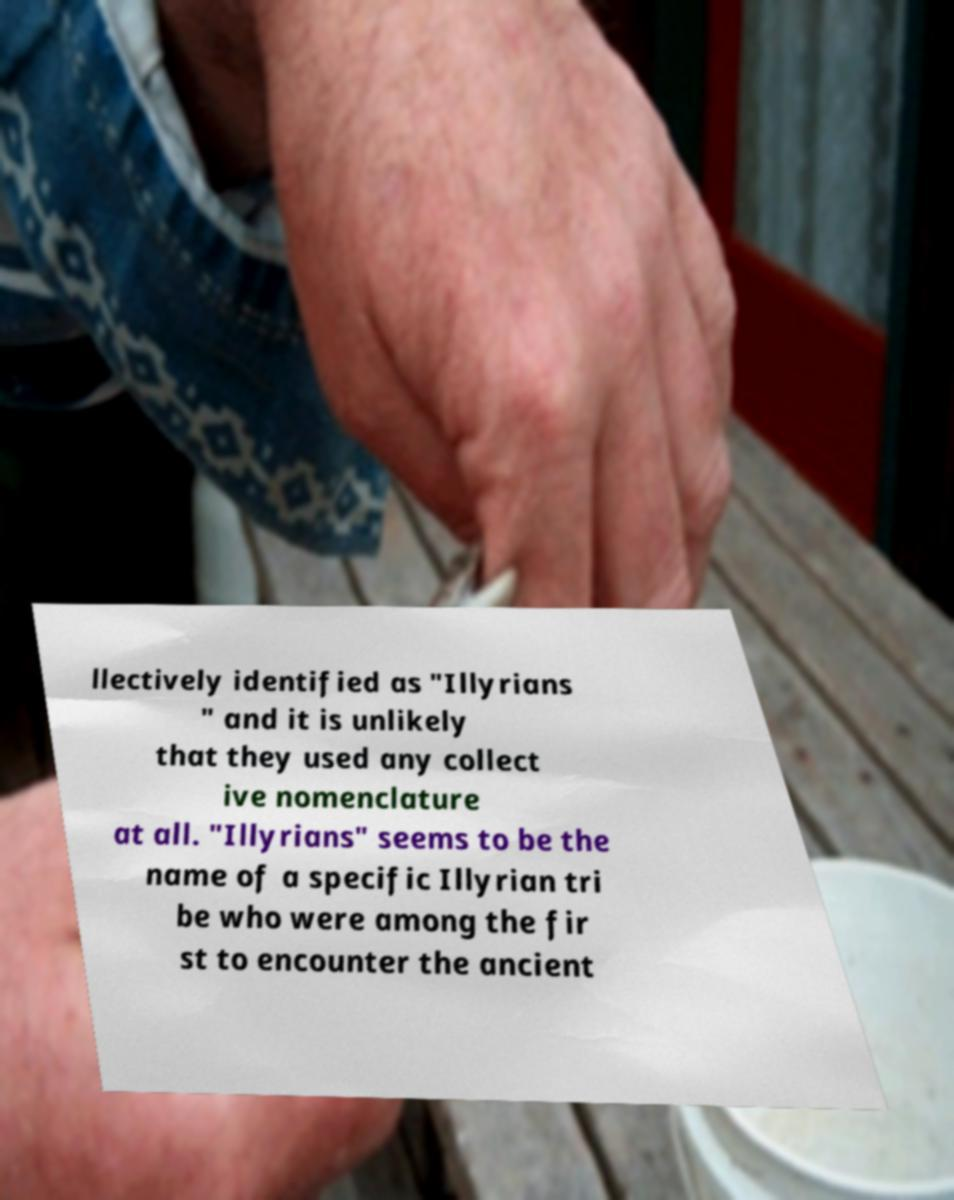For documentation purposes, I need the text within this image transcribed. Could you provide that? llectively identified as "Illyrians " and it is unlikely that they used any collect ive nomenclature at all. "Illyrians" seems to be the name of a specific Illyrian tri be who were among the fir st to encounter the ancient 